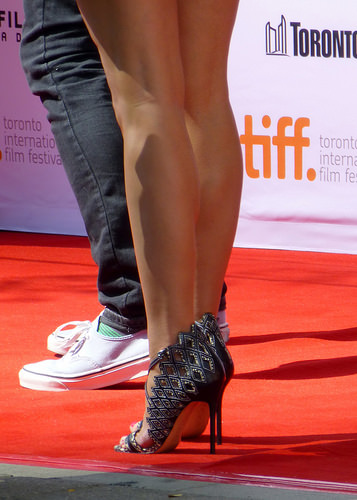<image>
Can you confirm if the woman is behind the man? Yes. From this viewpoint, the woman is positioned behind the man, with the man partially or fully occluding the woman. 